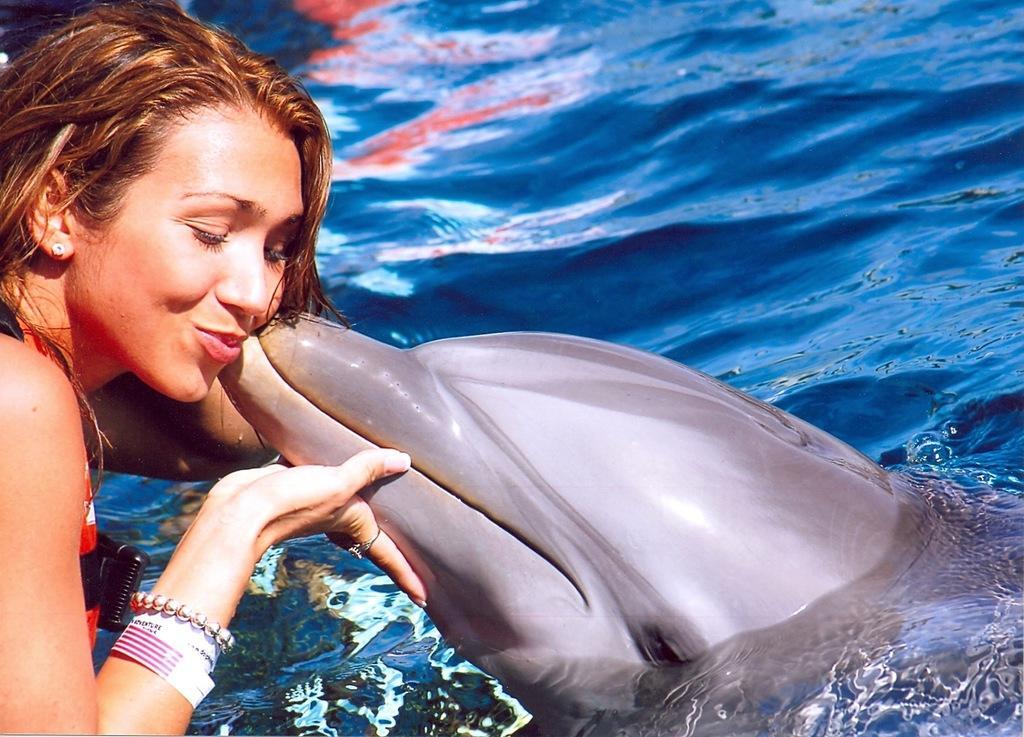Please provide a concise description of this image. In this image there is a woman at the left side corner is holding a dolphin which is in water. 